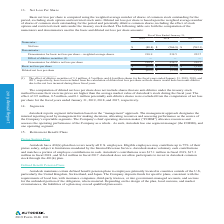According to Autodesk's financial document, Where are reclassifications related to gains and losses on available-for-sale debt securities included in? Based on the financial document, the answer is Reclassifications related to gains and losses on available-for-sale debt securities are included in "Interest and other expense, net".. Also, What was the total balance as of January 31, 2019? Based on the financial document, the answer is $(135.0) (in millions). Also, What was the total tax effects as of January 31, 2018? Based on the financial document, the answer is (2.6) (in millions). Also, can you calculate: What was the change in total balances from 2018 to 2019? Based on the calculation: 135.0-123.8, the result is 11.2 (in millions). The key data points involved are: 123.8, 135.0. Also, can you calculate: What is the average total balance from 2017 to 2019? To answer this question, I need to perform calculations using the financial data. The calculation is: (178.5+123.8+135.0)/3, which equals 145.77 (in millions). The key data points involved are: 123.8, 135.0, 178.5. Also, can you calculate: What is the average total balance from 2017 to 2019? To answer this question, I need to perform calculations using the financial data. The calculation is: (178.5+123.8+135.0)/3 , which equals 145.77 (in millions). The key data points involved are: 123.8, 135.0, 178.5. 